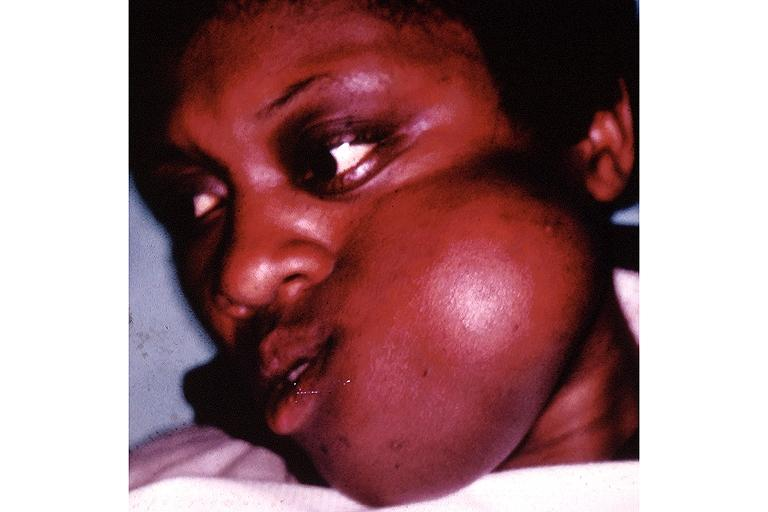s right leaf of diaphragm present?
Answer the question using a single word or phrase. No 